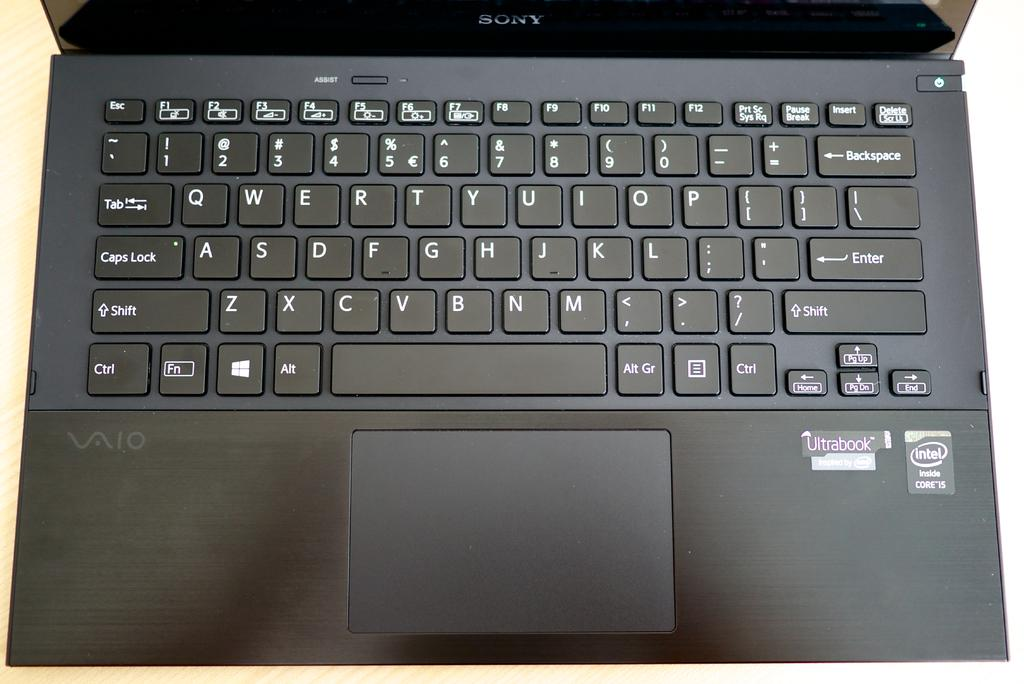Provide a one-sentence caption for the provided image. A Sony laptop is opened showing the keyboard. 